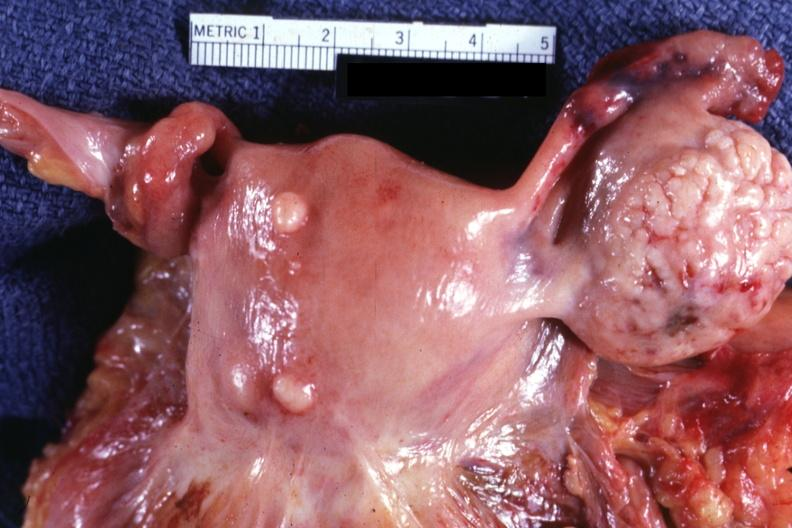what does this image show?
Answer the question using a single word or phrase. External view of uterus with two small subserosal myomas 